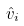Convert formula to latex. <formula><loc_0><loc_0><loc_500><loc_500>\hat { v } _ { i }</formula> 